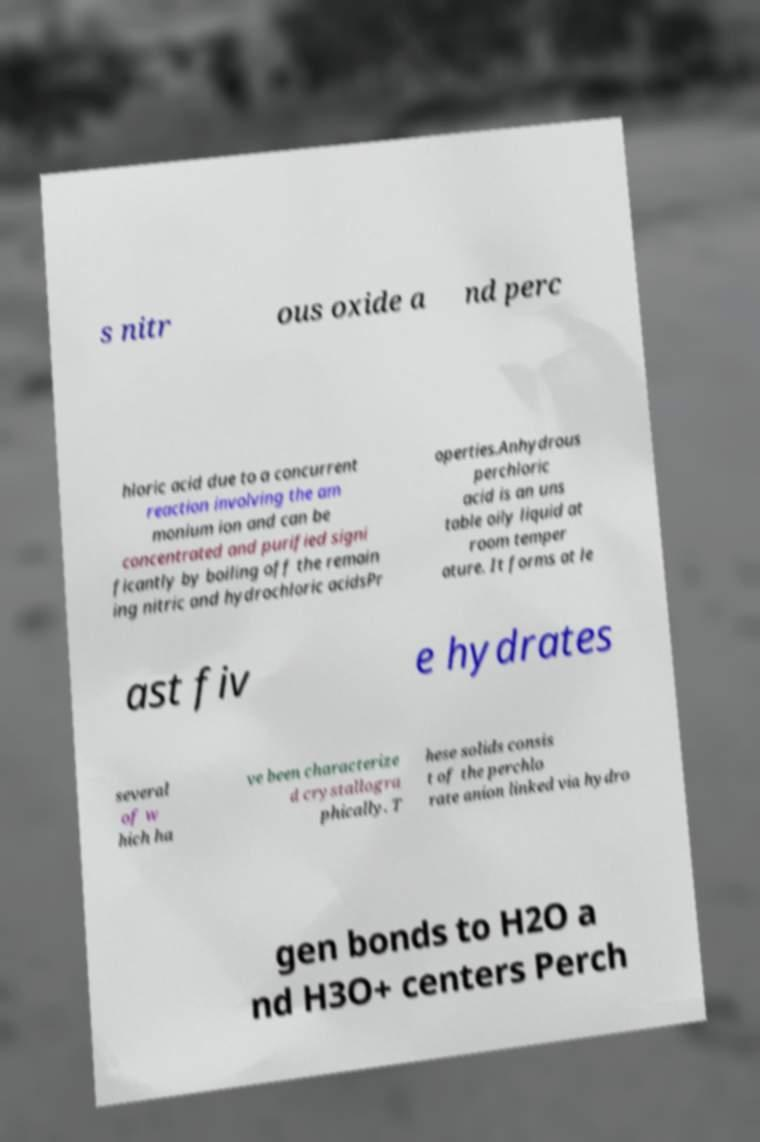Please read and relay the text visible in this image. What does it say? s nitr ous oxide a nd perc hloric acid due to a concurrent reaction involving the am monium ion and can be concentrated and purified signi ficantly by boiling off the remain ing nitric and hydrochloric acidsPr operties.Anhydrous perchloric acid is an uns table oily liquid at room temper ature. It forms at le ast fiv e hydrates several of w hich ha ve been characterize d crystallogra phically. T hese solids consis t of the perchlo rate anion linked via hydro gen bonds to H2O a nd H3O+ centers Perch 